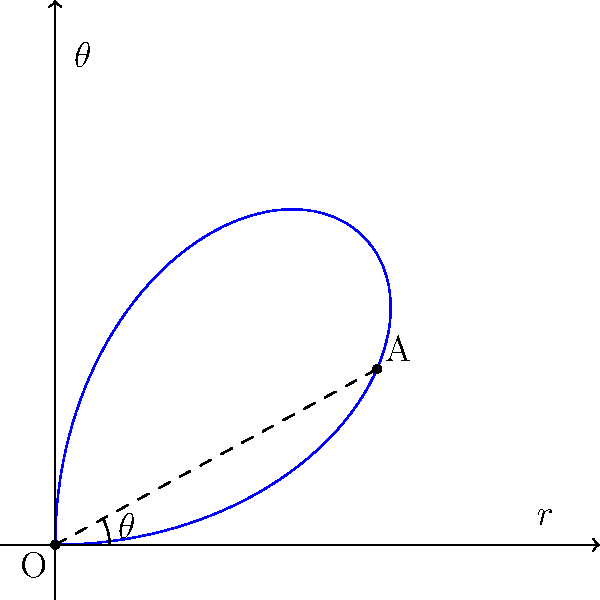In your coverage of the 1961 javelin throw event, you recorded the trajectory using polar coordinates. The path of the javelin can be described by the equation $r = 80\sin(2\theta)$, where $r$ is in meters and $\theta$ is in radians. At what angle $\theta$ (in radians) does the javelin reach its maximum distance from the origin? To find the angle at which the javelin reaches its maximum distance, we need to follow these steps:

1) The distance from the origin is given by $r = 80\sin(2\theta)$.

2) To find the maximum value of $r$, we need to find where $\frac{dr}{d\theta} = 0$.

3) Differentiating $r$ with respect to $\theta$:
   
   $\frac{dr}{d\theta} = 80 \cdot 2 \cos(2\theta) = 160\cos(2\theta)$

4) Setting this equal to zero:
   
   $160\cos(2\theta) = 0$

5) Solving for $\theta$:
   
   $\cos(2\theta) = 0$
   
   This occurs when $2\theta = \frac{\pi}{2}$ or $\frac{3\pi}{2}$

6) Therefore, $\theta = \frac{\pi}{4}$ or $\frac{3\pi}{4}$

7) Since we're only considering the first quadrant (as per the graph), the answer is $\frac{\pi}{4}$ radians.
Answer: $\frac{\pi}{4}$ radians 